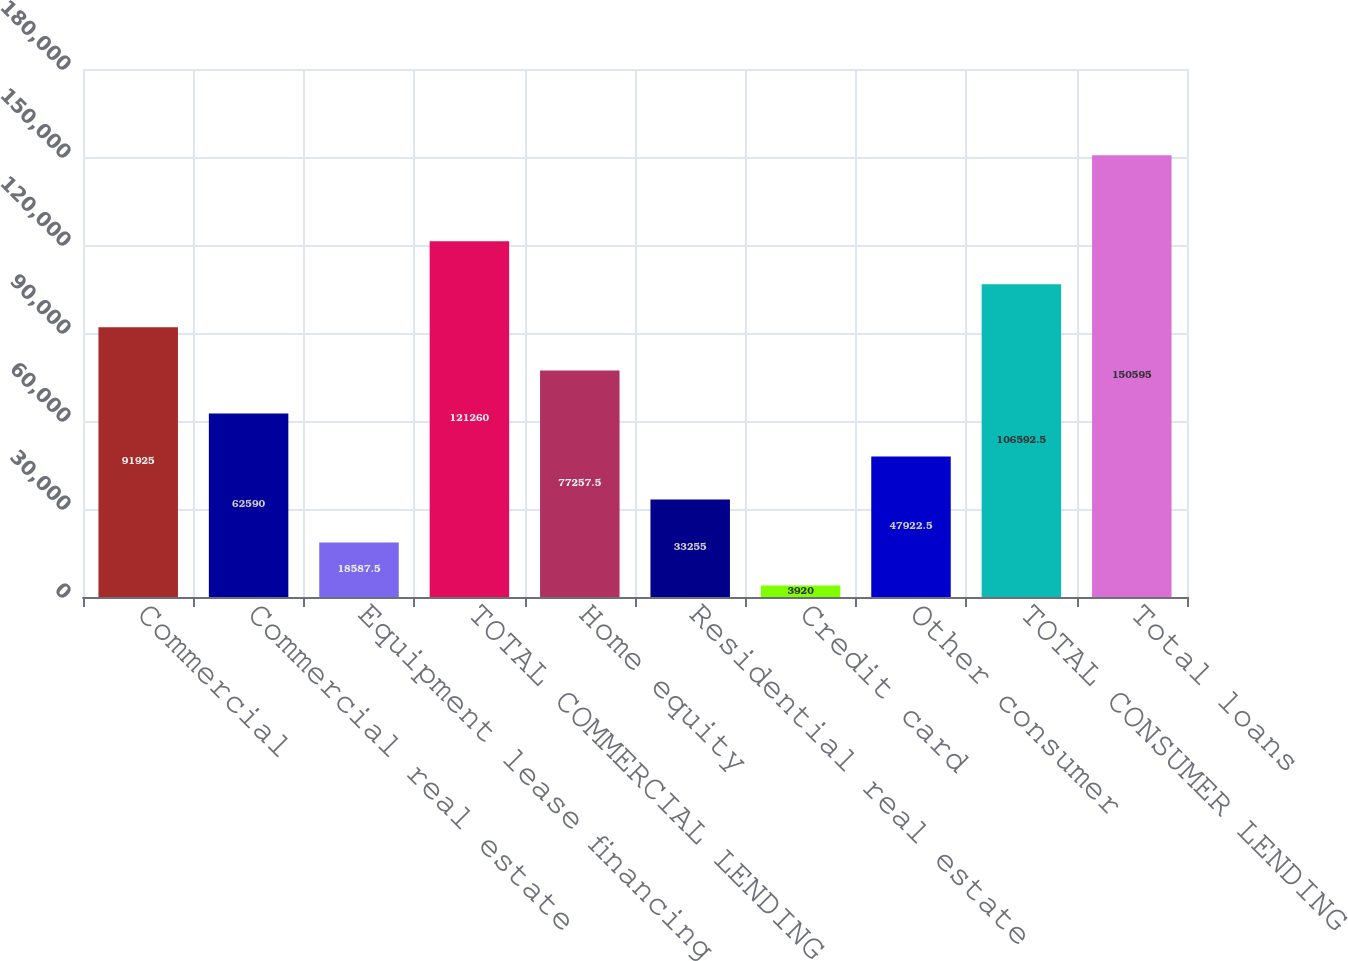<chart> <loc_0><loc_0><loc_500><loc_500><bar_chart><fcel>Commercial<fcel>Commercial real estate<fcel>Equipment lease financing<fcel>TOTAL COMMERCIAL LENDING<fcel>Home equity<fcel>Residential real estate<fcel>Credit card<fcel>Other consumer<fcel>TOTAL CONSUMER LENDING<fcel>Total loans<nl><fcel>91925<fcel>62590<fcel>18587.5<fcel>121260<fcel>77257.5<fcel>33255<fcel>3920<fcel>47922.5<fcel>106592<fcel>150595<nl></chart> 